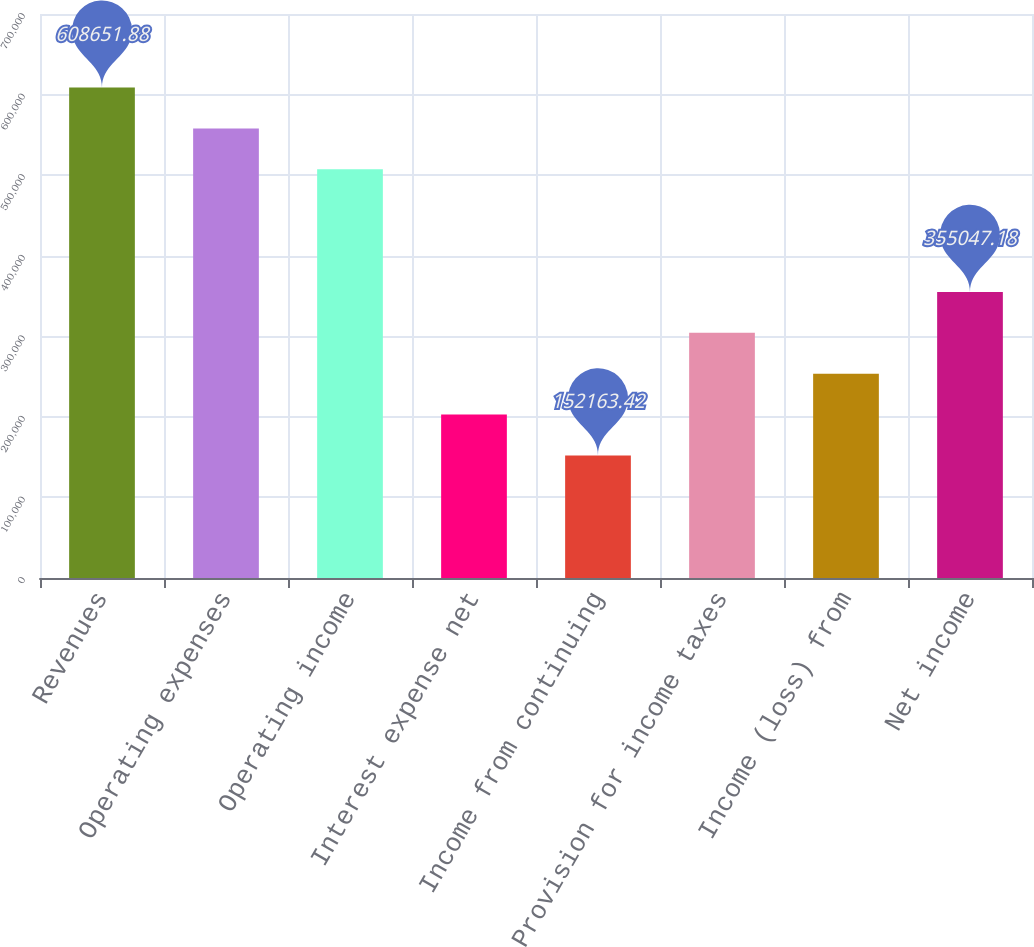<chart> <loc_0><loc_0><loc_500><loc_500><bar_chart><fcel>Revenues<fcel>Operating expenses<fcel>Operating income<fcel>Interest expense net<fcel>Income from continuing<fcel>Provision for income taxes<fcel>Income (loss) from<fcel>Net income<nl><fcel>608652<fcel>557931<fcel>507210<fcel>202884<fcel>152163<fcel>304326<fcel>253605<fcel>355047<nl></chart> 